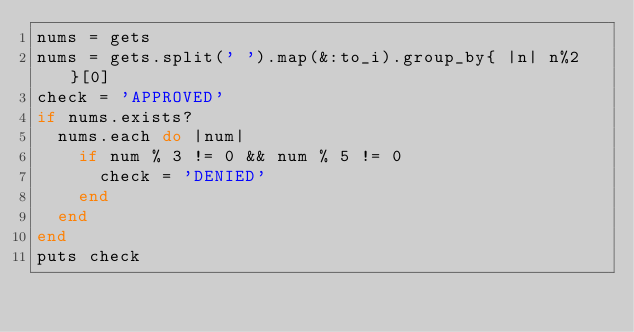<code> <loc_0><loc_0><loc_500><loc_500><_Ruby_>nums = gets
nums = gets.split(' ').map(&:to_i).group_by{ |n| n%2 }[0]
check = 'APPROVED'
if nums.exists?
  nums.each do |num|
    if num % 3 != 0 && num % 5 != 0
      check = 'DENIED'
    end
  end
end
puts check</code> 